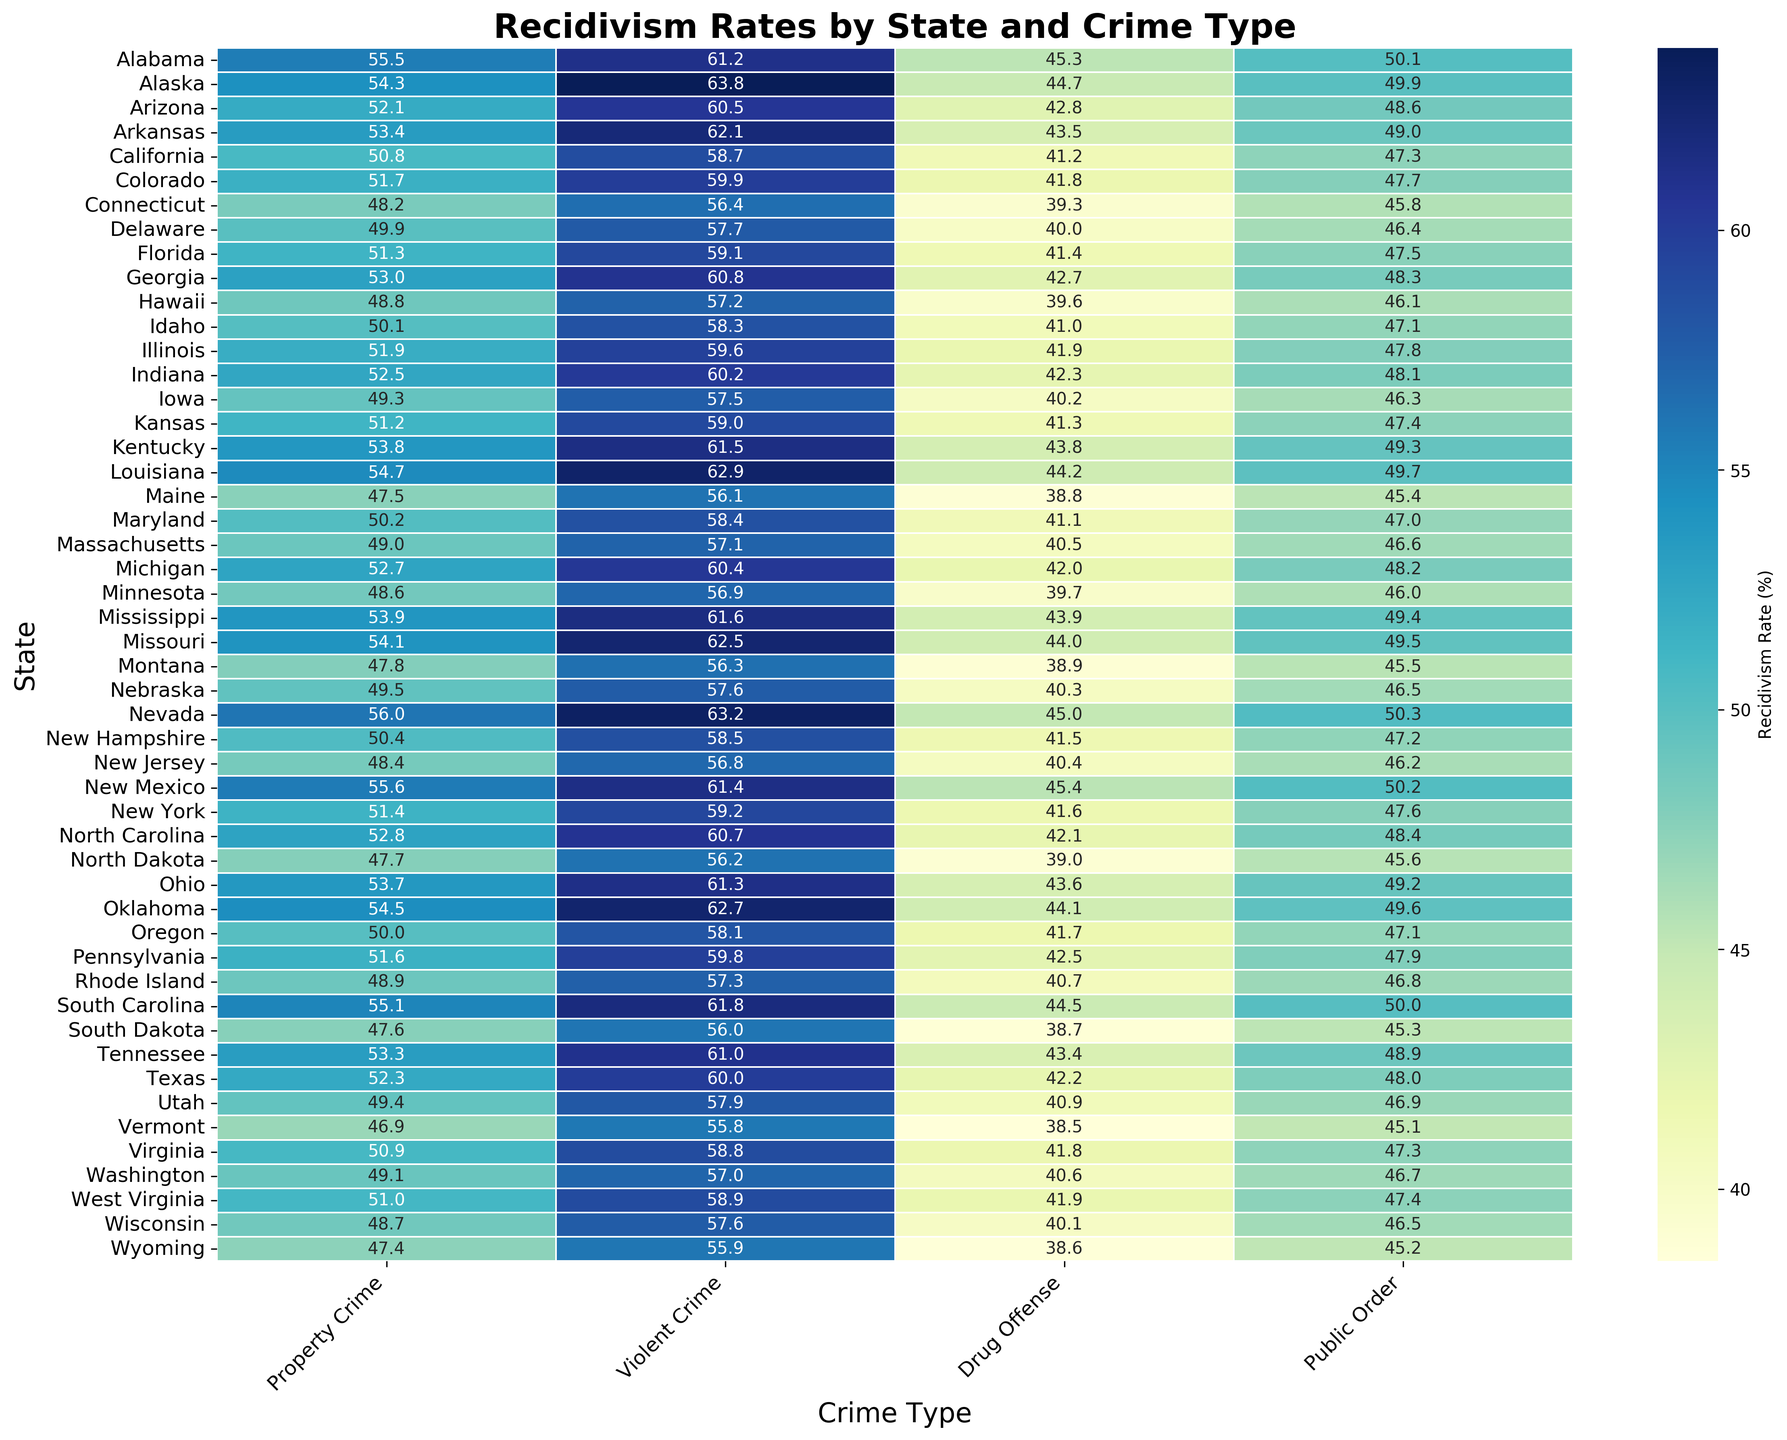Which state has the highest recidivism rate for violent crimes? To determine this, look at the "Violent Crime" column and identify the maximum value. The highest percentage is 63.8% for Alaska.
Answer: Alaska Which state has the lowest recidivism rate for public order offenses? To find this, scan the "Public Order" column for the lowest percentage. The lowest value is 45.1% for Vermont.
Answer: Vermont What is the average recidivism rate for property crimes in all states? Sum the recidivism rates for "Property Crime" for all states and divide by the number of states. The average is calculated as (sum of all rates divided by the number of states) which comes out to approximately 51.7%.
Answer: 51.7% How does New Mexico's recidivism rate for drug offenses compare to the national average? Determine New Mexico's percentage for “Drug Offense” from the heatmap, which is 45.4%. Then, calculate the average “Drug Offense” recidivism rate across all states and compare. The national average for drug offenses is approximately 41.8%. New Mexico's rate is higher than the national average.
Answer: Higher Which state shows the largest difference in recidivism rates between property crimes and drug offenses, and what is that difference? Calculate the differences between "Property Crime" and "Drug Offense" for each state and identify the maximum difference. For Nevada, the difference is (56.0% - 45.0% = 11.0%), which is the largest.
Answer: Nevada, 11.0% How does the recidivism rate for violent crimes in Florida compare to that in New York? Check the percentages for "Violent Crime" for both Florida (59.1%) and New York (59.2%) from the heatmap, and note which is higher. New York's rate is slightly higher by 0.1%.
Answer: New York What is the range of recidivism rates for drug offenses across all states? Identify the highest (New Mexico at 45.4%) and the lowest rates (Vermont at 38.5%) in the "Drug Offense" column, then subtract the lowest from the highest to get the range. The range is (45.4% - 38.5%) = 6.9%.
Answer: 6.9% Which state has a recidivism rate for public order offenses closest to 47%? Scan the "Public Order" column and find the value closest to 47.0%. Maryland has a recidivism rate of 47.0% for public order offenses.
Answer: Maryland 